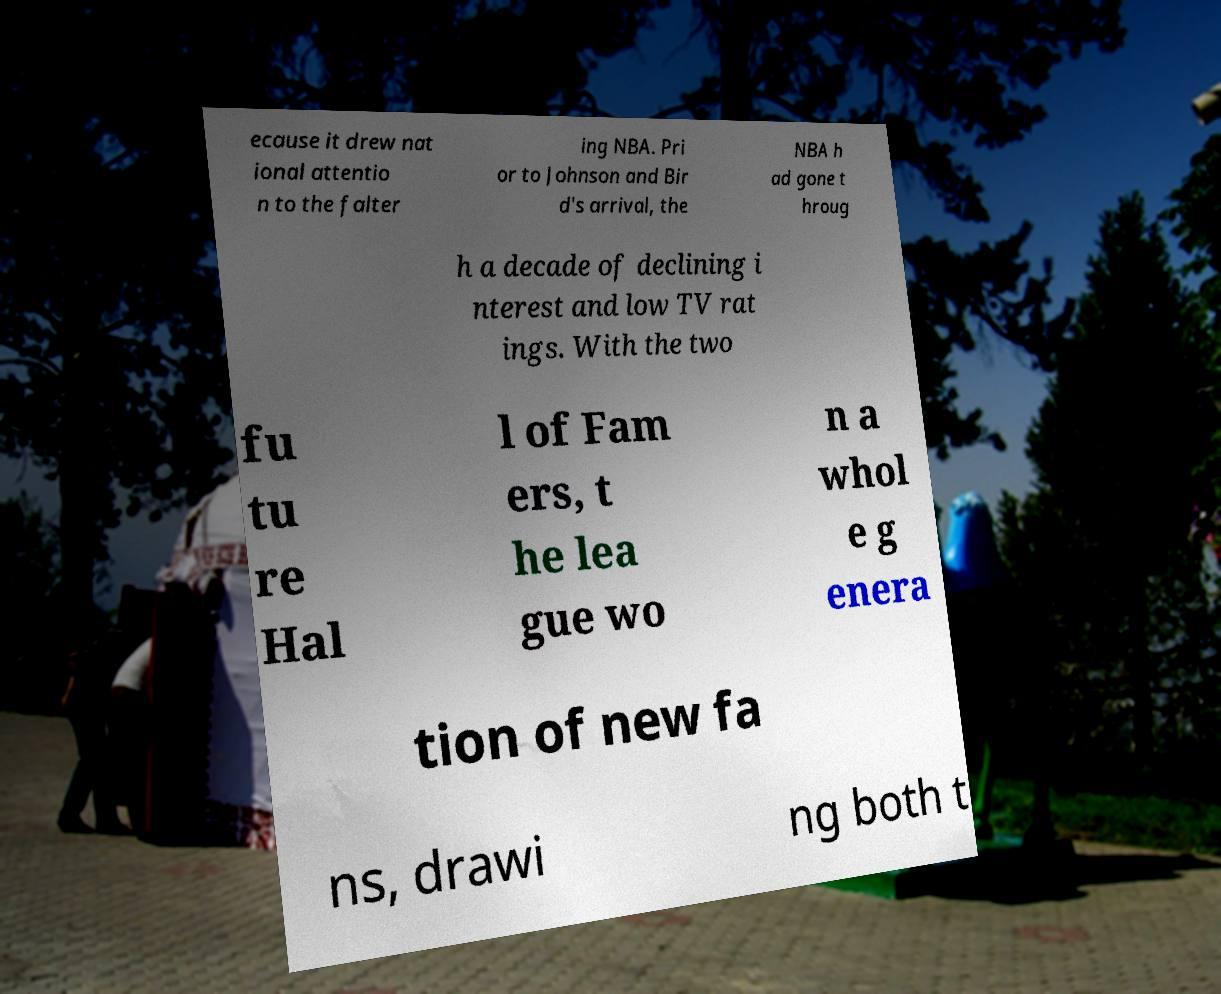Please identify and transcribe the text found in this image. ecause it drew nat ional attentio n to the falter ing NBA. Pri or to Johnson and Bir d's arrival, the NBA h ad gone t hroug h a decade of declining i nterest and low TV rat ings. With the two fu tu re Hal l of Fam ers, t he lea gue wo n a whol e g enera tion of new fa ns, drawi ng both t 